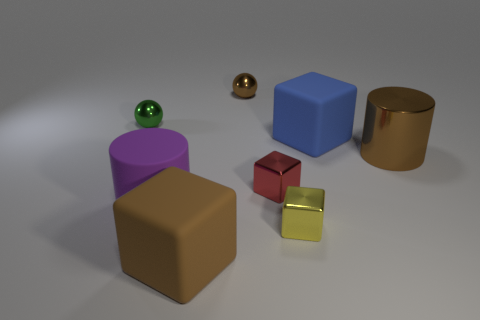Add 2 red shiny cylinders. How many objects exist? 10 Subtract all cylinders. How many objects are left? 6 Subtract 0 gray balls. How many objects are left? 8 Subtract all big blue metallic cylinders. Subtract all small objects. How many objects are left? 4 Add 2 metallic things. How many metallic things are left? 7 Add 2 tiny purple balls. How many tiny purple balls exist? 2 